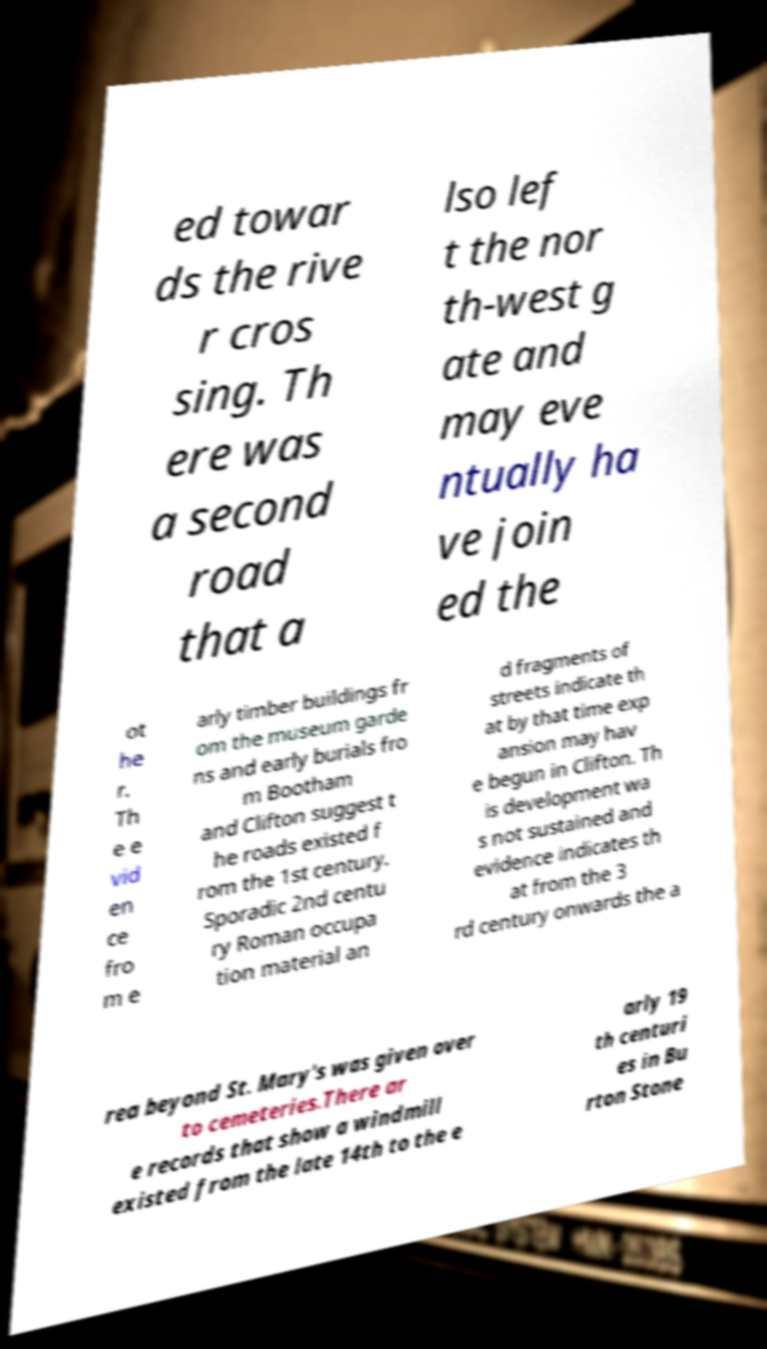Please read and relay the text visible in this image. What does it say? ed towar ds the rive r cros sing. Th ere was a second road that a lso lef t the nor th-west g ate and may eve ntually ha ve join ed the ot he r. Th e e vid en ce fro m e arly timber buildings fr om the museum garde ns and early burials fro m Bootham and Clifton suggest t he roads existed f rom the 1st century. Sporadic 2nd centu ry Roman occupa tion material an d fragments of streets indicate th at by that time exp ansion may hav e begun in Clifton. Th is development wa s not sustained and evidence indicates th at from the 3 rd century onwards the a rea beyond St. Mary's was given over to cemeteries.There ar e records that show a windmill existed from the late 14th to the e arly 19 th centuri es in Bu rton Stone 